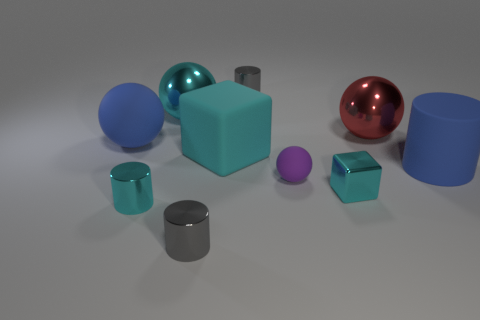What number of things are either small balls that are to the right of the big cyan metal thing or cylinders? 5 